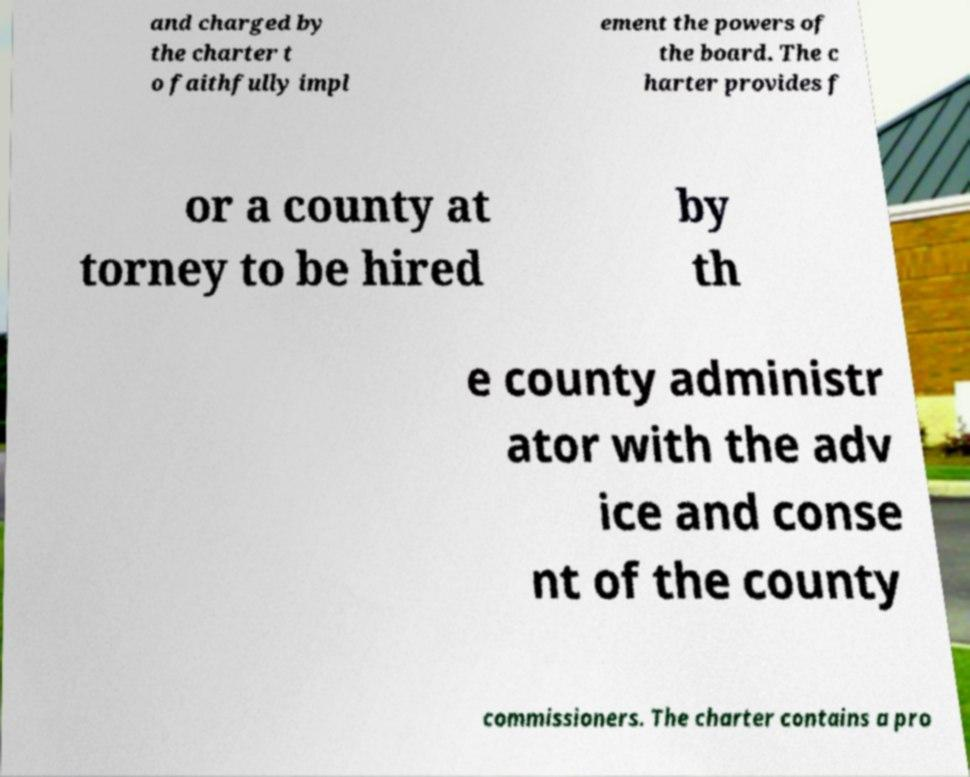What messages or text are displayed in this image? I need them in a readable, typed format. and charged by the charter t o faithfully impl ement the powers of the board. The c harter provides f or a county at torney to be hired by th e county administr ator with the adv ice and conse nt of the county commissioners. The charter contains a pro 